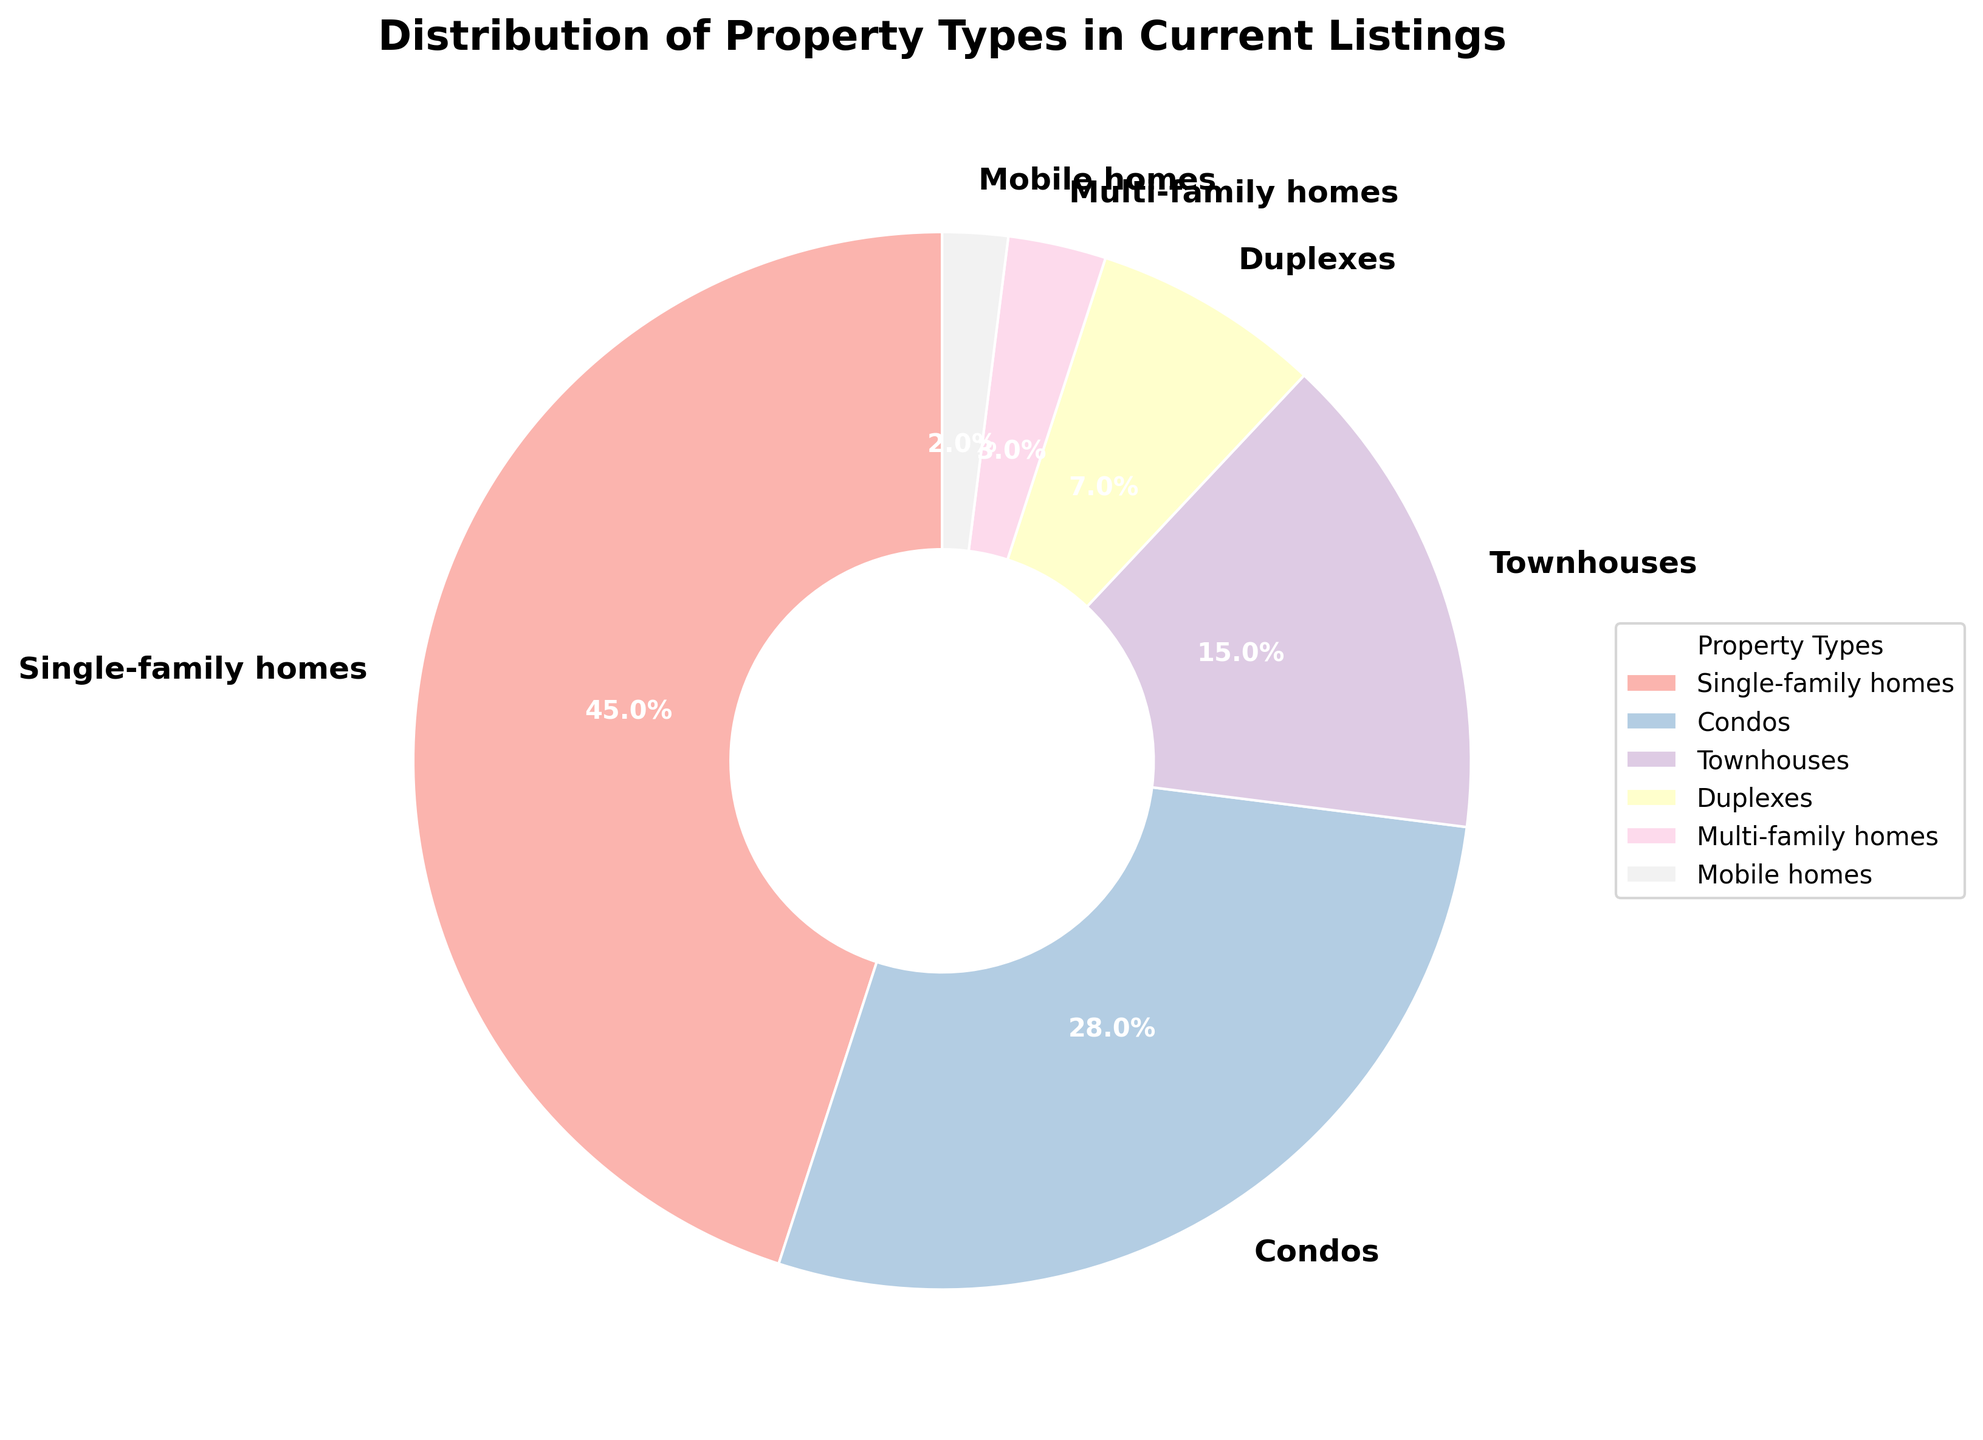Which property type has the largest percentage in the current listings? To find the property type with the largest percentage, look for the category with the highest percentage value in the pie chart. In the figure, single-family homes have a percentage of 45%, the highest among all property types.
Answer: Single-family homes What percentage of the listings are Condos? To determine the percentage of Condos, refer to the specific label on the pie chart. Condos are listed with a percentage of 28%.
Answer: 28% How much more common are single-family homes compared to townhouses? To compare the commonality of single-family homes and townhouses, subtract the percentage of townhouses from the percentage of single-family homes. Single-family homes are 45%, and townhouses are 15%, so 45% - 15% = 30%.
Answer: 30% What is the combined percentage of multi-family homes and mobile homes? To find the combined percentage of multi-family homes and mobile homes, add their percentages together. Multi-family homes are 3% and mobile homes are 2%, so 3% + 2% = 5%.
Answer: 5% Which property type is the least common in the current listings? To identify the least common property type, look for the smallest percentage value in the pie chart. Mobile homes have the smallest percentage at 2%.
Answer: Mobile homes How does the percentage of duplexes compare to the percentage of single-family homes? To compare the percentages, note the respective values. Duplexes are 7% and single-family homes are 45%. Single-family homes have a much higher percentage than duplexes.
Answer: Single-family homes have a higher percentage If you were to combine the percentages of condos and townhouses, would it be more or less than the percentage of single-family homes? Add the percentages of condos and townhouses: 28% (condos) + 15% (townhouses) = 43%. Compare this with the percentage of single-family homes, which is 45%. 43% is less than 45%, so it would be less.
Answer: Less What is the ratio of single-family homes to duplexes in the current listings? To find the ratio, divide the percentage of single-family homes by the percentage of duplexes. Single-family homes are 45% and duplexes are 7%. The ratio is 45:7.
Answer: 45:7 What proportion of the listings are either townhouses or duplexes? Add the percentages of townhouses and duplexes. Townhouses are 15%, and duplexes are 7%, so 15% + 7% = 22%.
Answer: 22% How does the combined percentage of mobile homes and multi-family homes compare to duplexes? Add the percentages of mobile homes and multi-family homes together: 2% + 3% = 5%. Compare this with the percentage of duplexes, which is 7%. 5% is less than 7%.
Answer: Less 